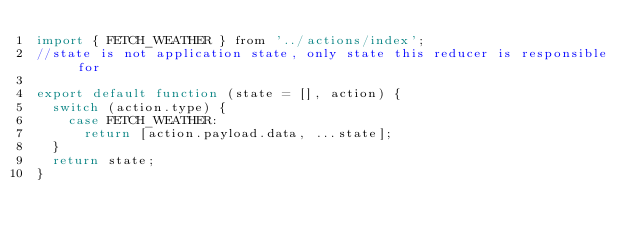<code> <loc_0><loc_0><loc_500><loc_500><_JavaScript_>import { FETCH_WEATHER } from '../actions/index';
//state is not application state, only state this reducer is responsible for

export default function (state = [], action) {
  switch (action.type) {
    case FETCH_WEATHER:
      return [action.payload.data, ...state];
  }
  return state;
}</code> 